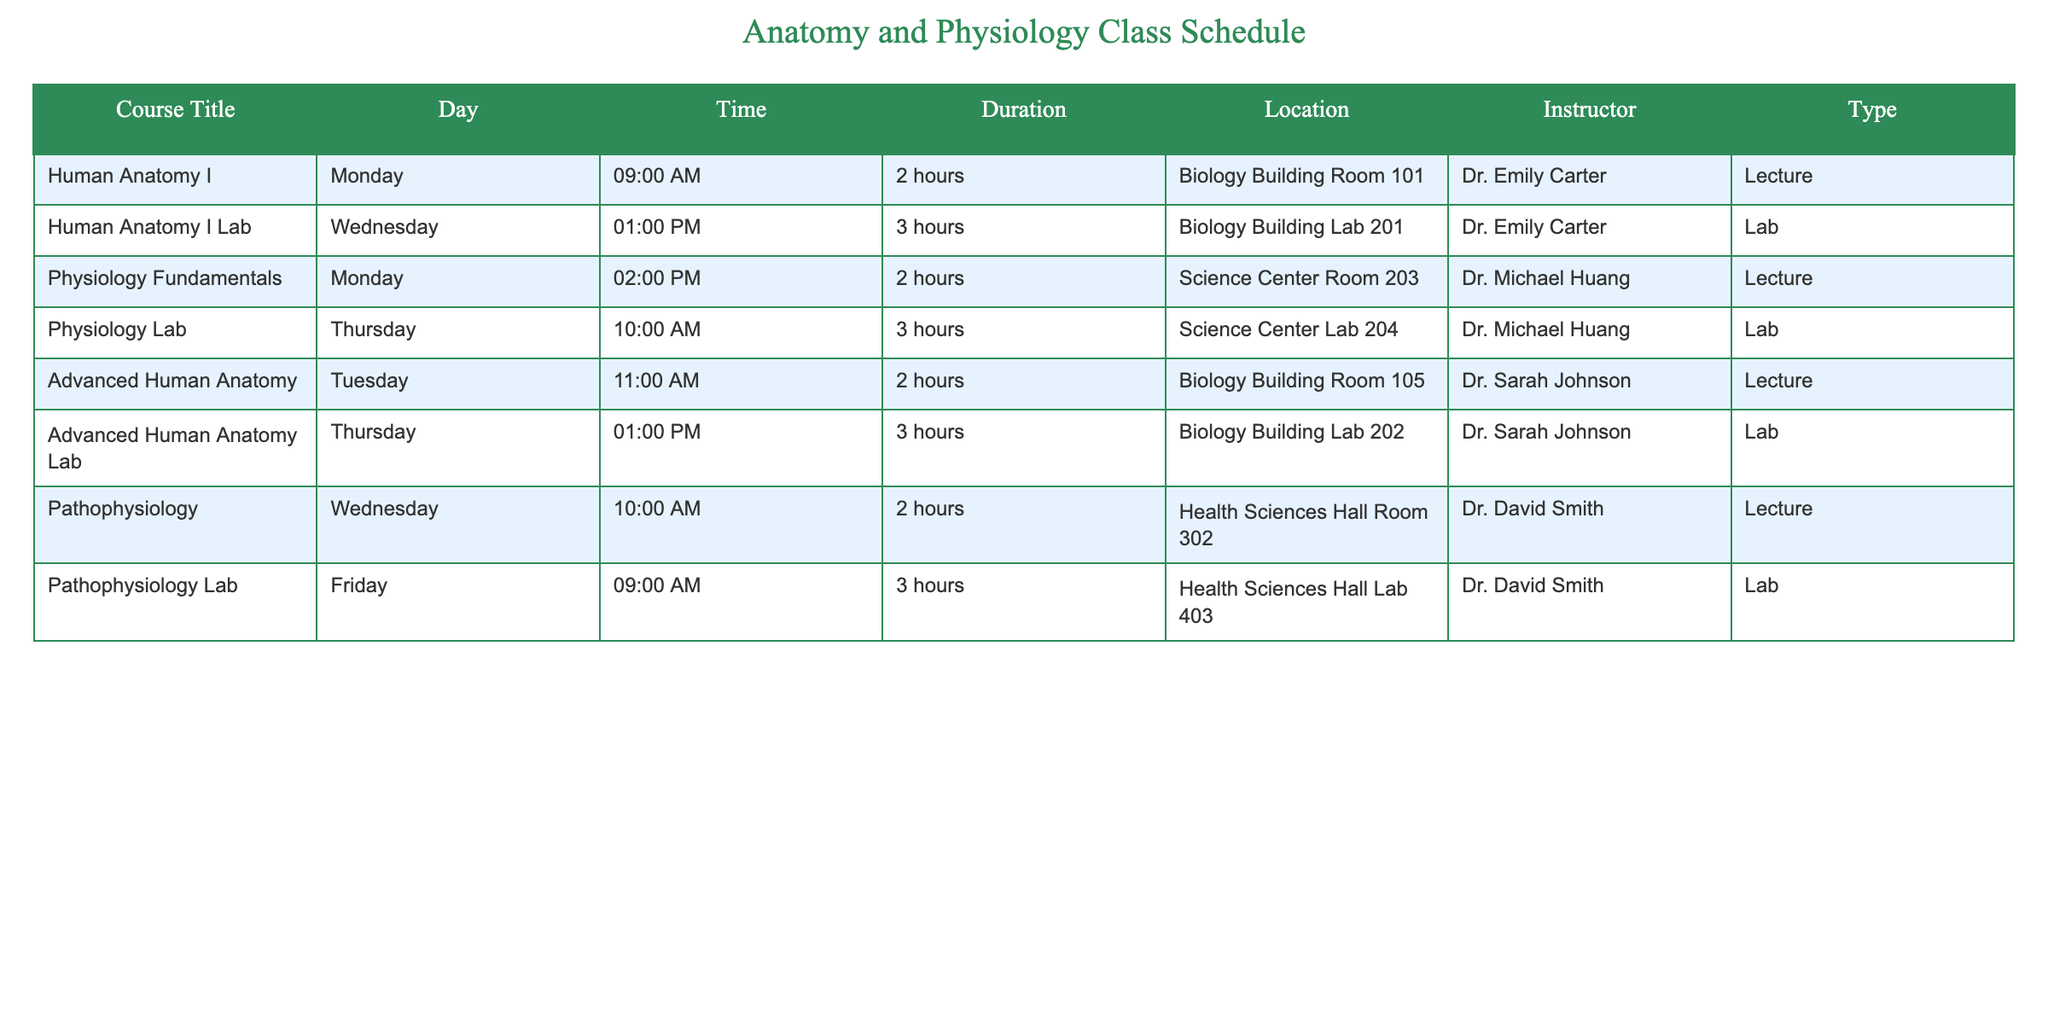What day and time is the Human Anatomy I Lab scheduled? The table indicates that the Human Anatomy I Lab is listed under the "Day" column with "Wednesday" and the "Time" column specifies "01:00 PM." Therefore, the scheduled time for the lab is Wednesday at 1 PM.
Answer: Wednesday at 1 PM How long does the Pathophysiology lecture last? The duration of the Pathophysiology lecture can be found in the "Duration" column associated with the "Pathophysiology" entry, which states it lasts for "2 hours."
Answer: 2 hours Which courses are conducted by Dr. Sarah Johnson? By looking at the "Instructor" column, I see Dr. Sarah Johnson teaches "Advanced Human Anatomy" and "Advanced Human Anatomy Lab." Thus, her courses include both lecture and lab associated with advanced anatomy.
Answer: Advanced Human Anatomy and Advanced Human Anatomy Lab What is the total duration of lab sessions in the schedule? The total duration of lab sessions is calculated by adding the durations of each lab session: Human Anatomy I Lab (3 hours) + Physiology Lab (3 hours) + Advanced Human Anatomy Lab (3 hours) + Pathophysiology Lab (3 hours) = 3 + 3 + 3 + 3 = 12 hours.
Answer: 12 hours Does the schedule include any lab sessions on Mondays? Checking the "Day" column for any lab sessions on Monday, it appears no lab sessions are listed for that day. The closest lab, the Human Anatomy I Lab, occurs on Wednesday. Thus, there are no lab sessions on Monday.
Answer: No Which course has the latest start time on Thursdays? The latest starting course on Thursday is the Advanced Human Anatomy Lab which takes place at 01:00 PM, while the Physiology Lab starts at 10:00 AM. Hence, Advanced Human Anatomy Lab has the latest time on that day.
Answer: Advanced Human Anatomy Lab What is the average duration of lectures in the classes scheduled? To find the average duration of the lectures, I identify all lecture durations: Human Anatomy I (2 hours), Physiology Fundamentals (2 hours), Advanced Human Anatomy (2 hours), and Pathophysiology (2 hours). Summing these gives: 2 + 2 + 2 + 2 = 8 hours. Then, divide by the number of lectures: 8 hours / 4 lectures = 2 hours average duration.
Answer: 2 hours Is there any class taught by Dr. David Smith on Tuesday? Upon examining the "Instructor" column for Dr. David Smith's classes, none are scheduled on Tuesday. He teaches classes on Wednesday and Friday, so there is no class for him on Tuesday.
Answer: No 